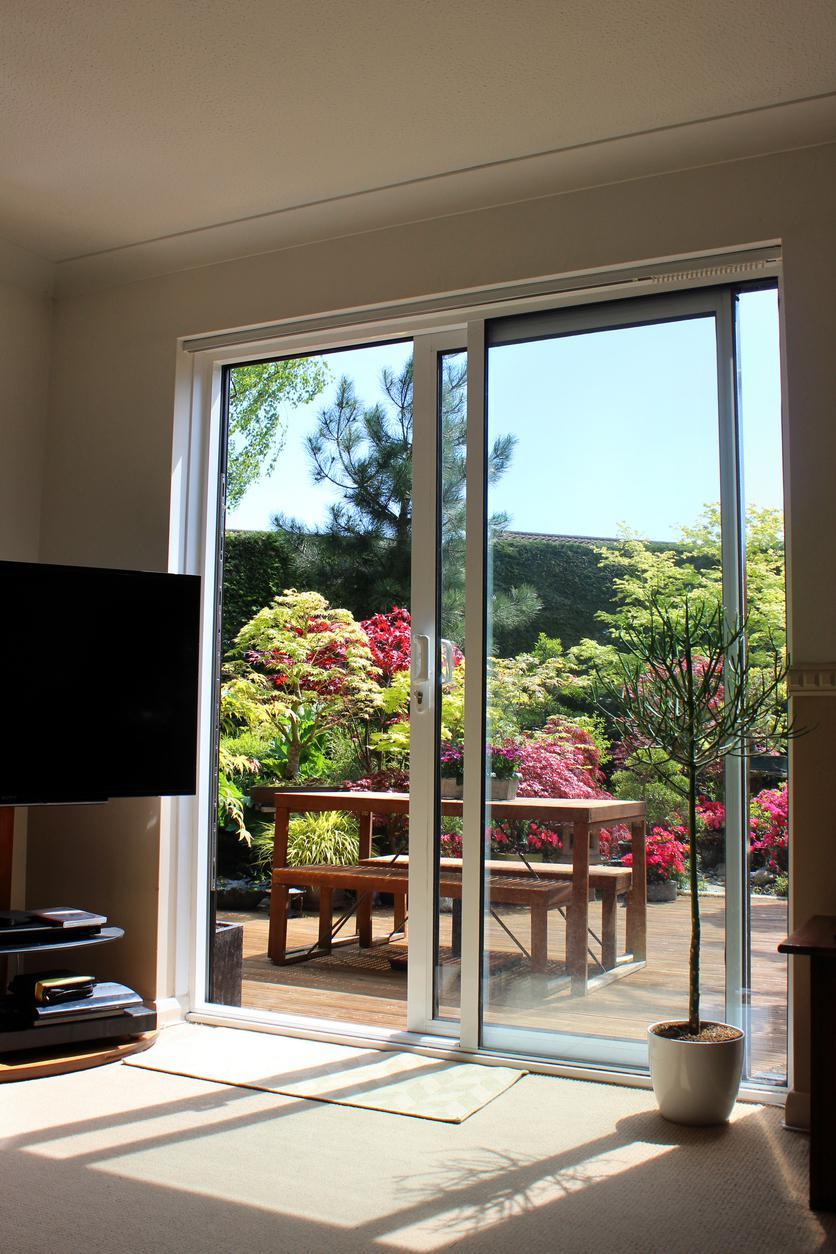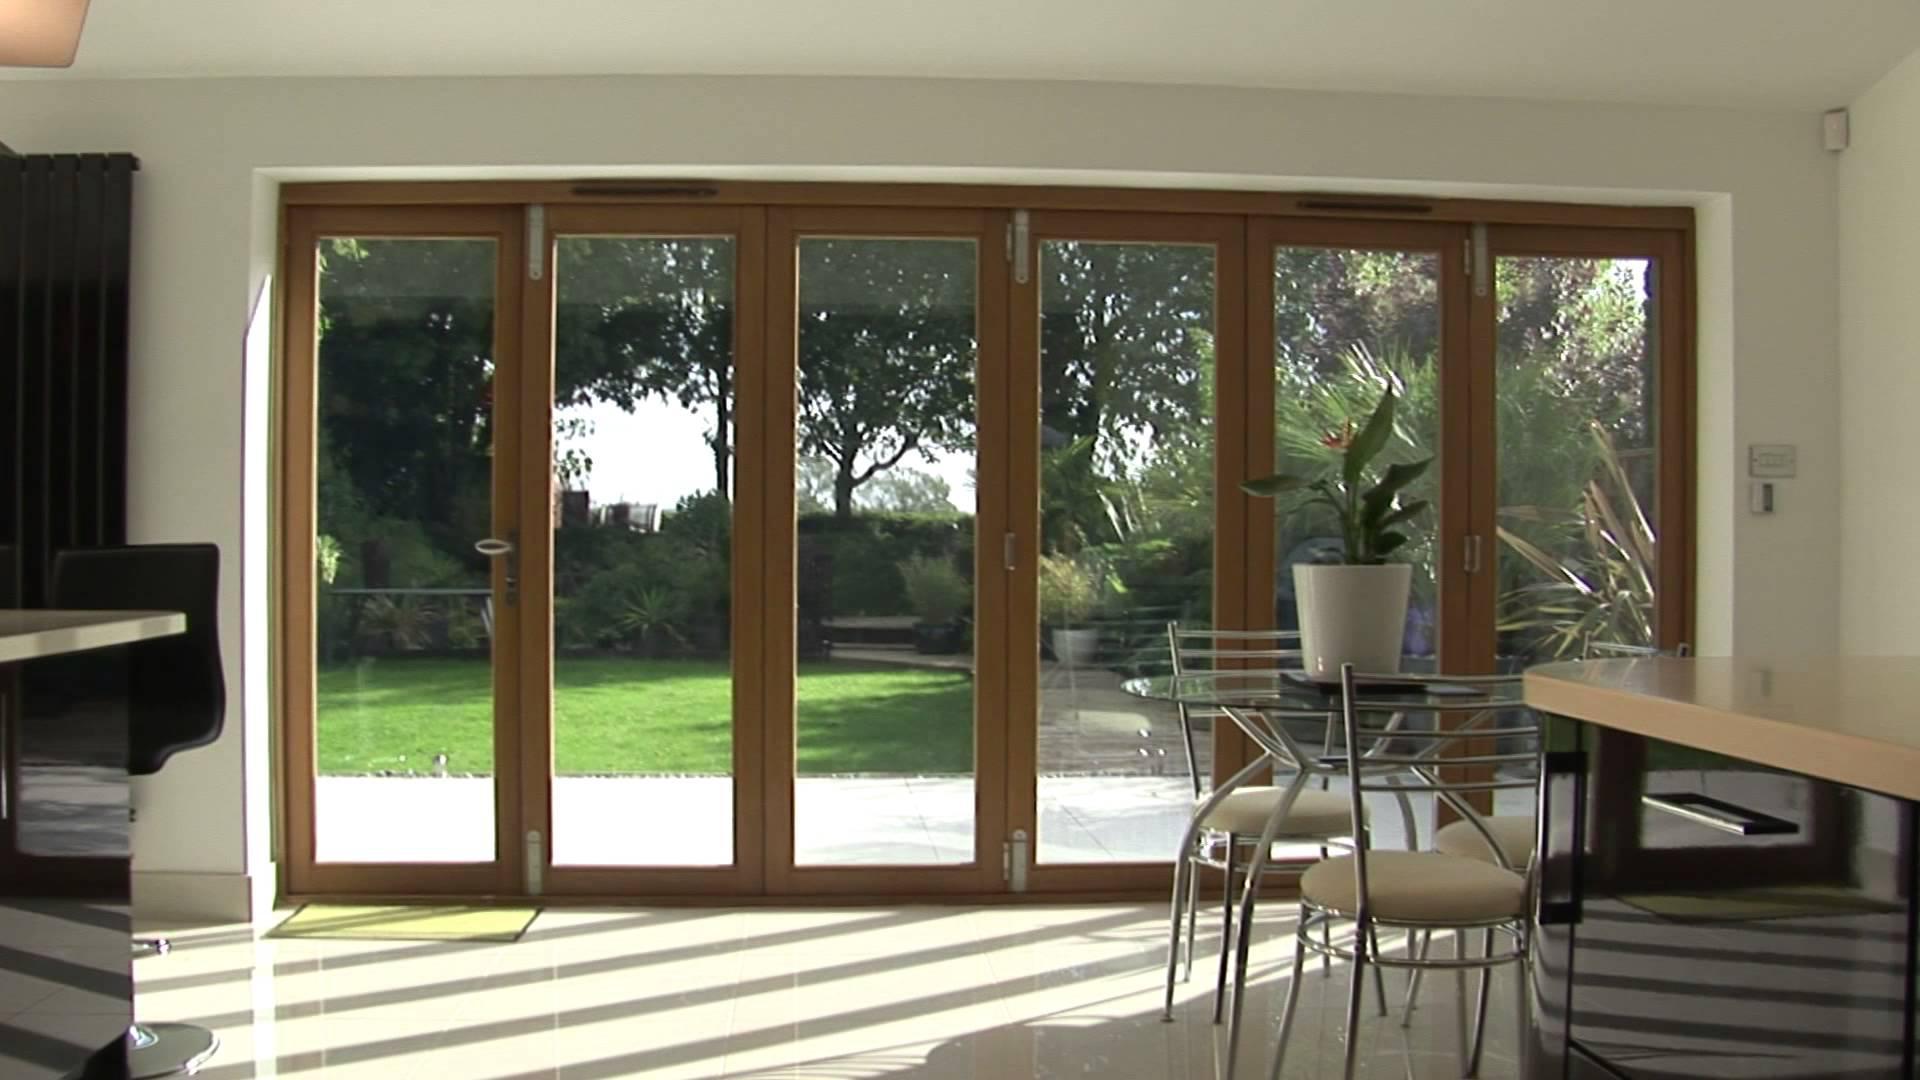The first image is the image on the left, the second image is the image on the right. Assess this claim about the two images: "Some doors have a wood trim.". Correct or not? Answer yes or no. Yes. The first image is the image on the left, the second image is the image on the right. Assess this claim about the two images: "There are six glass panes in a row in the right image.". Correct or not? Answer yes or no. Yes. 